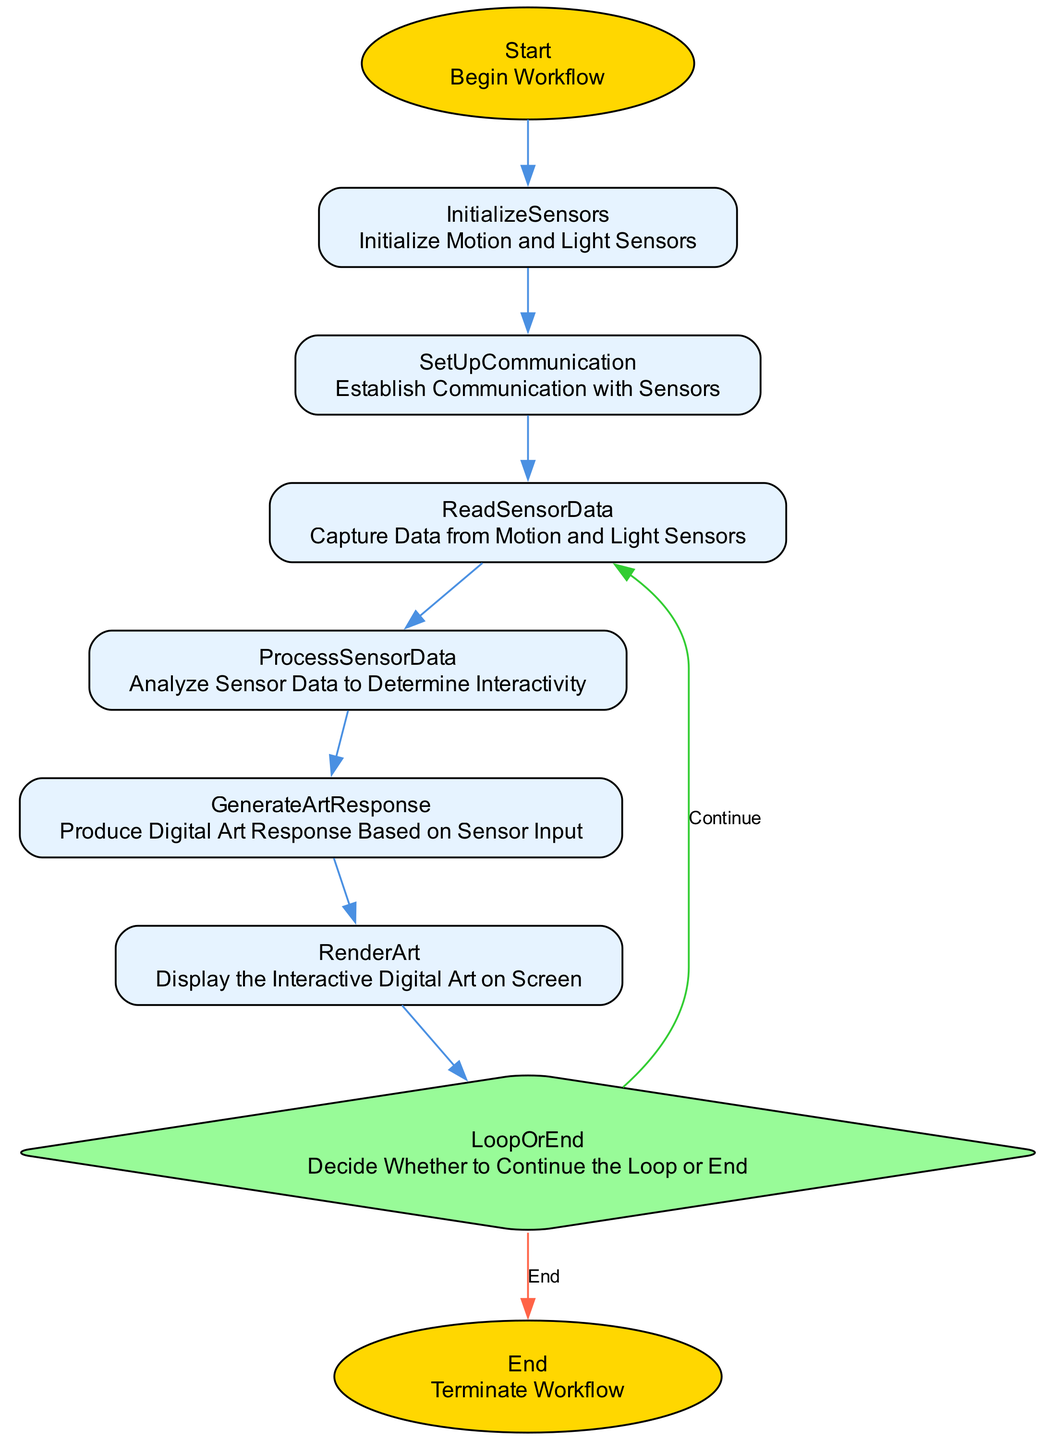What is the first step in the workflow? The first step is labeled as 'Start', which indicates the beginning of the workflow process.
Answer: Start How many steps are there in the workflow? Counting each unique step outlined in the diagram, there are a total of nine unique steps.
Answer: Nine What is the final step in the workflow? The final step is labeled as 'End', which signifies the termination of the workflow process.
Answer: End Which step comes directly after 'InitializeSensors'? The step that follows 'InitializeSensors' is 'SetUpCommunication', indicating the process moves to establishing communication with the sensors after initialization.
Answer: SetUpCommunication What decision does the flowchart lead to at the 'LoopOrEnd' step? At the 'LoopOrEnd' step, the decision is whether to 'Continue' the loop or to 'End' the process. This choice determines if the workflow restarts or concludes.
Answer: Continue How many edges lead out from the 'LoopOrEnd' node? There are two edges that lead out from the 'LoopOrEnd' node: one continues to 'ReadSensorData', and the other leads to 'End'.
Answer: Two Which two steps are connected by the edge labeled 'End'? The edge labeled 'End' connects 'LoopOrEnd' to 'End', indicating the termination of the workflow based on the decision made at the 'LoopOrEnd' step.
Answer: LoopOrEnd to End What shape is used for 'ProcessSensorData'? 'ProcessSensorData' is represented as a rectangle in the diagram, indicating it is a standard processing step within the workflow.
Answer: Rectangle What does the step 'GenerateArtResponse' do in the workflow? The 'GenerateArtResponse' step produces a digital art response based on the input received from the sensor data, indicating its role in creating an interactive experience.
Answer: Produce Digital Art Response 